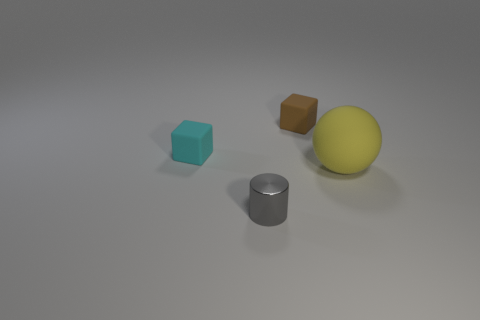Add 2 blocks. How many objects exist? 6 Subtract all cylinders. How many objects are left? 3 Add 1 matte blocks. How many matte blocks are left? 3 Add 2 matte spheres. How many matte spheres exist? 3 Subtract 0 blue cylinders. How many objects are left? 4 Subtract all tiny blue blocks. Subtract all small brown matte blocks. How many objects are left? 3 